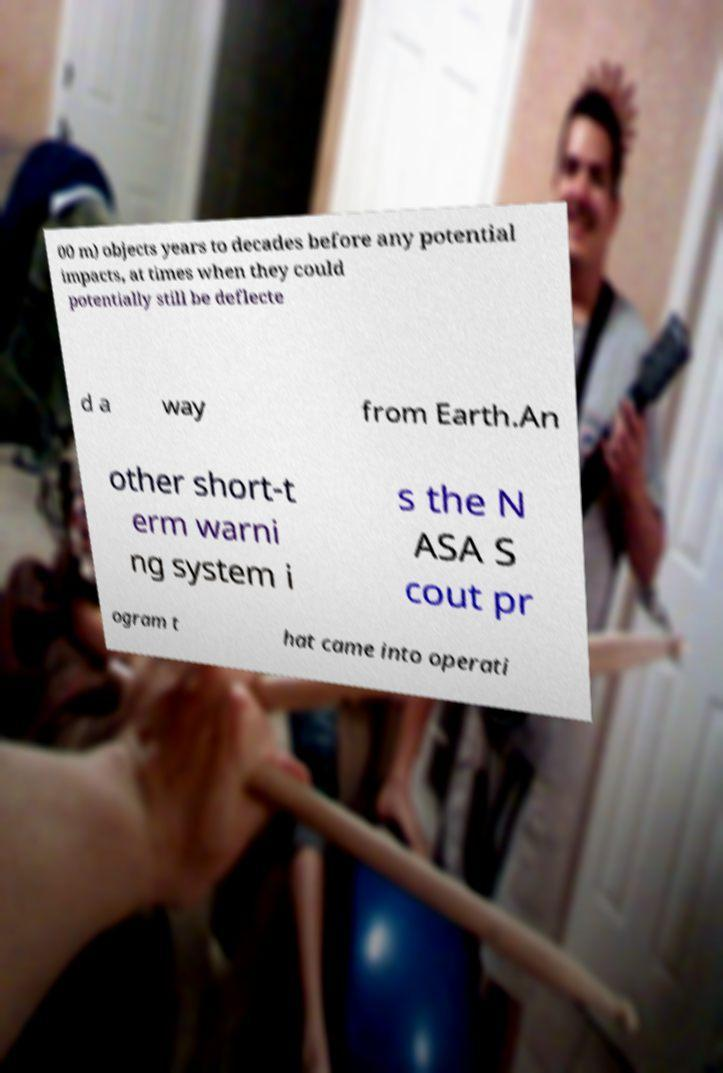There's text embedded in this image that I need extracted. Can you transcribe it verbatim? 00 m) objects years to decades before any potential impacts, at times when they could potentially still be deflecte d a way from Earth.An other short-t erm warni ng system i s the N ASA S cout pr ogram t hat came into operati 